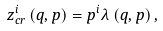Convert formula to latex. <formula><loc_0><loc_0><loc_500><loc_500>z _ { c r } ^ { i } \left ( q , p \right ) = p ^ { i } \lambda \left ( q , p \right ) ,</formula> 